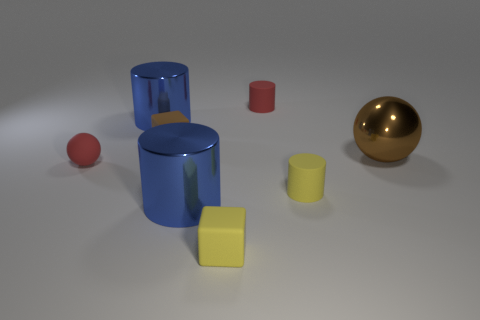How many tiny yellow metal blocks are there?
Offer a terse response. 0. Are there any yellow matte objects that have the same size as the brown shiny sphere?
Make the answer very short. No. Are there fewer tiny brown rubber things that are in front of the red matte ball than cyan objects?
Provide a short and direct response. No. Do the yellow rubber block and the red cylinder have the same size?
Keep it short and to the point. Yes. The red ball that is made of the same material as the small brown cube is what size?
Your answer should be very brief. Small. What number of small cylinders have the same color as the small matte sphere?
Your response must be concise. 1. Are there fewer large metallic balls behind the brown rubber cube than metallic objects right of the yellow cylinder?
Ensure brevity in your answer.  Yes. There is a matte thing behind the brown block; does it have the same shape as the tiny brown object?
Make the answer very short. No. Are there any other things that are the same material as the tiny yellow block?
Ensure brevity in your answer.  Yes. Do the block that is behind the big metallic ball and the red cylinder have the same material?
Give a very brief answer. Yes. 